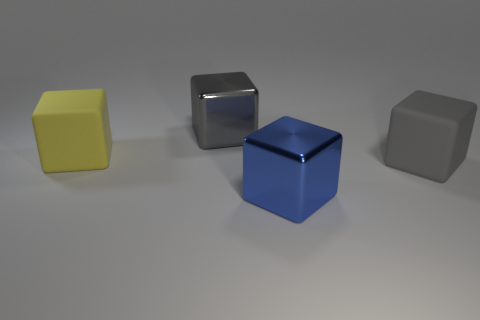Subtract all yellow spheres. How many gray cubes are left? 2 Subtract all blue cubes. How many cubes are left? 3 Subtract all large blue shiny blocks. How many blocks are left? 3 Subtract 2 blocks. How many blocks are left? 2 Add 3 big gray blocks. How many objects exist? 7 Subtract all green blocks. Subtract all cyan cylinders. How many blocks are left? 4 Subtract all large gray metallic things. Subtract all red things. How many objects are left? 3 Add 4 large gray shiny blocks. How many large gray shiny blocks are left? 5 Add 1 large yellow matte objects. How many large yellow matte objects exist? 2 Subtract 0 green balls. How many objects are left? 4 